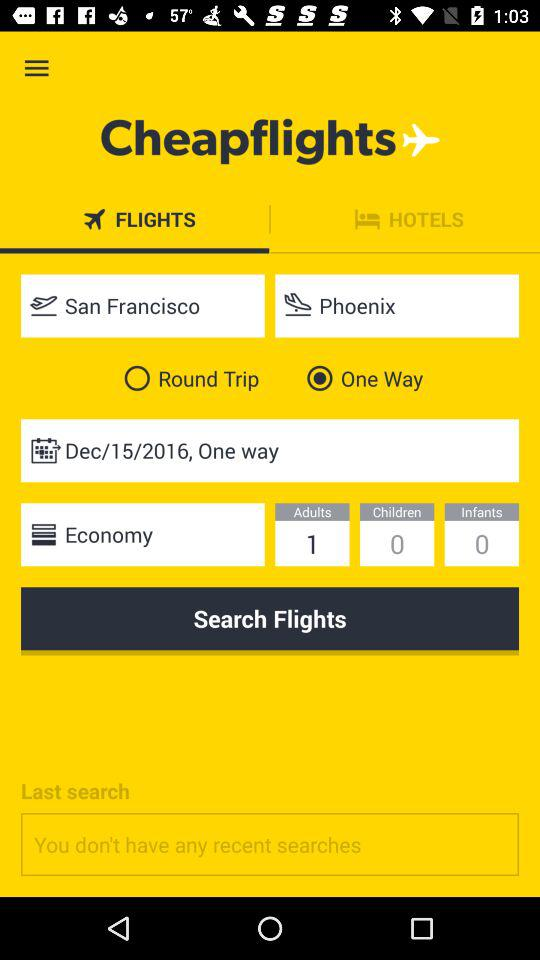How many more adults are there than children?
Answer the question using a single word or phrase. 1 